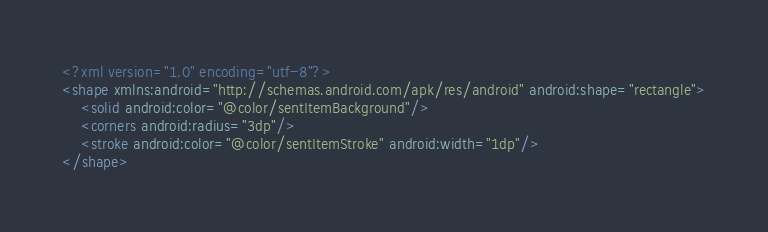Convert code to text. <code><loc_0><loc_0><loc_500><loc_500><_XML_><?xml version="1.0" encoding="utf-8"?>
<shape xmlns:android="http://schemas.android.com/apk/res/android" android:shape="rectangle">
    <solid android:color="@color/sentItemBackground"/>
    <corners android:radius="3dp"/>
    <stroke android:color="@color/sentItemStroke" android:width="1dp"/>
</shape></code> 